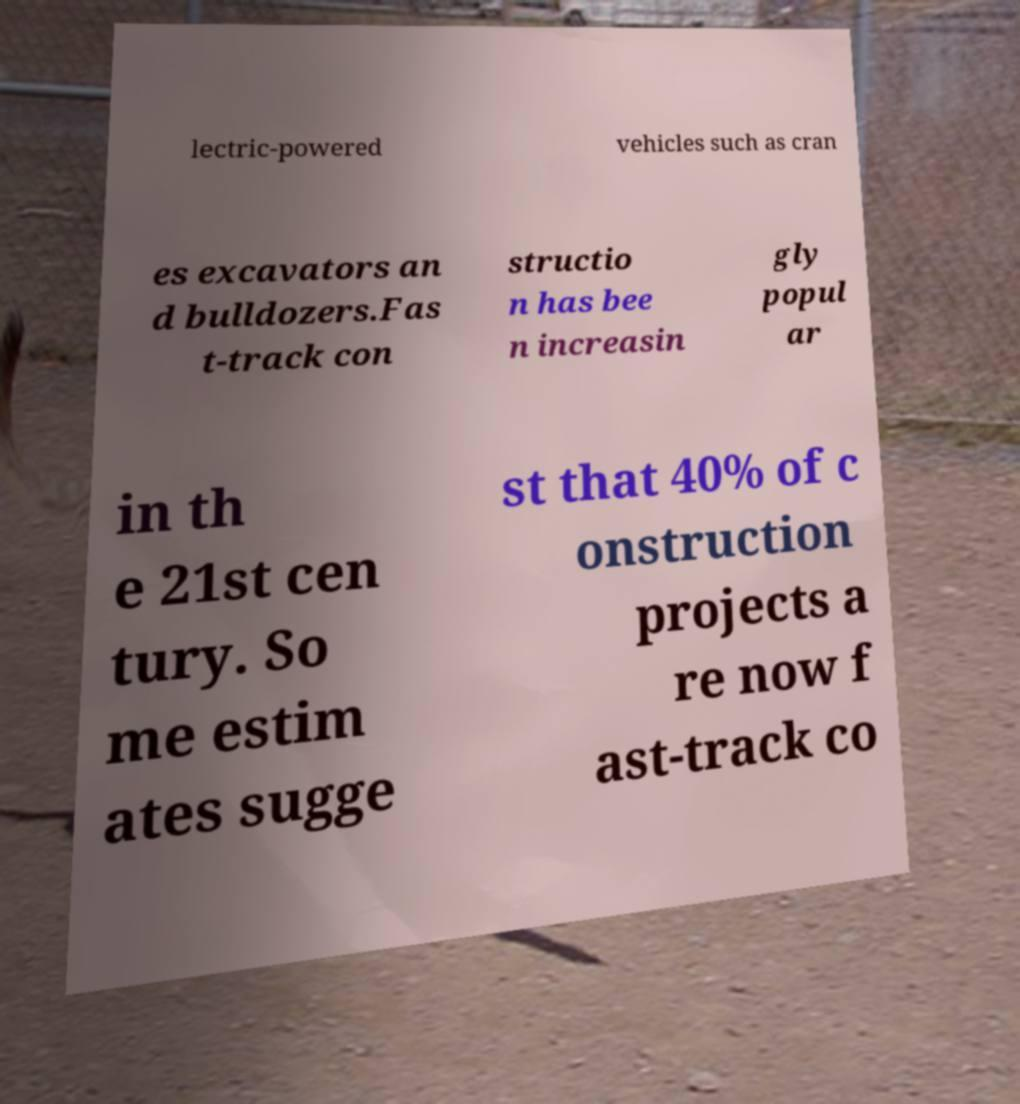Can you read and provide the text displayed in the image?This photo seems to have some interesting text. Can you extract and type it out for me? lectric-powered vehicles such as cran es excavators an d bulldozers.Fas t-track con structio n has bee n increasin gly popul ar in th e 21st cen tury. So me estim ates sugge st that 40% of c onstruction projects a re now f ast-track co 